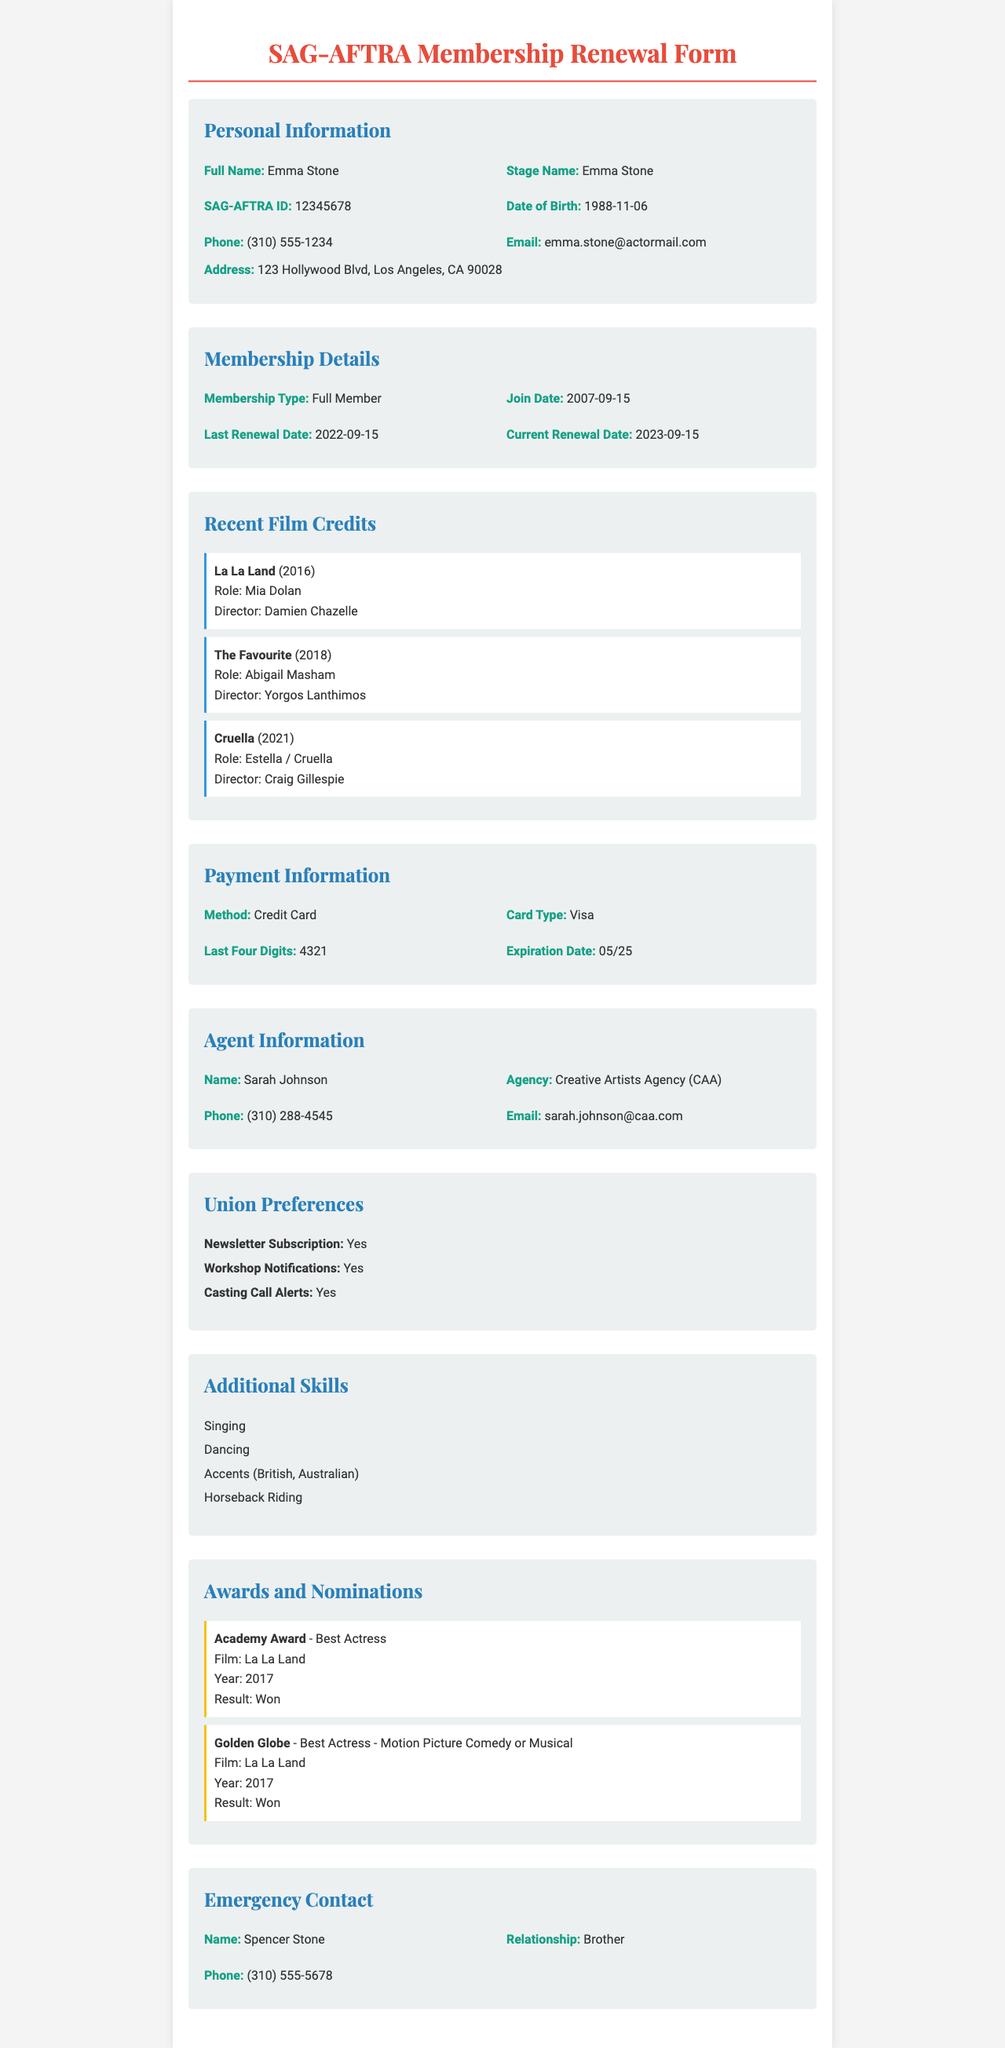what is the full name of the actor? The full name of the actor is mentioned under Personal Information in the document.
Answer: Emma Stone what is the SAG-AFTRA ID? The SAG-AFTRA ID can be found in the Membership Details section of the document.
Answer: 12345678 when was the last renewal date? The last renewal date is provided in the Membership Details section.
Answer: 2022-09-15 what role did Emma Stone play in "Cruella"? The role is listed under Recent Film Credits in the document.
Answer: Estella / Cruella who directed "The Favourite"? The director is provided in the Recent Film Credits section of the document.
Answer: Yorgos Lanthimos is there a newsletter subscription? This information can be found under Union Preferences.
Answer: Yes who is the emergency contact? The name of the emergency contact is specified under Emergency Contact.
Answer: Spencer Stone what payment method is used for the renewal? The payment method is detailed in the Payment Information section.
Answer: Credit Card how many awards did Emma Stone win for "La La Land"? The number of awards can be inferred from the Awards and Nominations section.
Answer: 2 